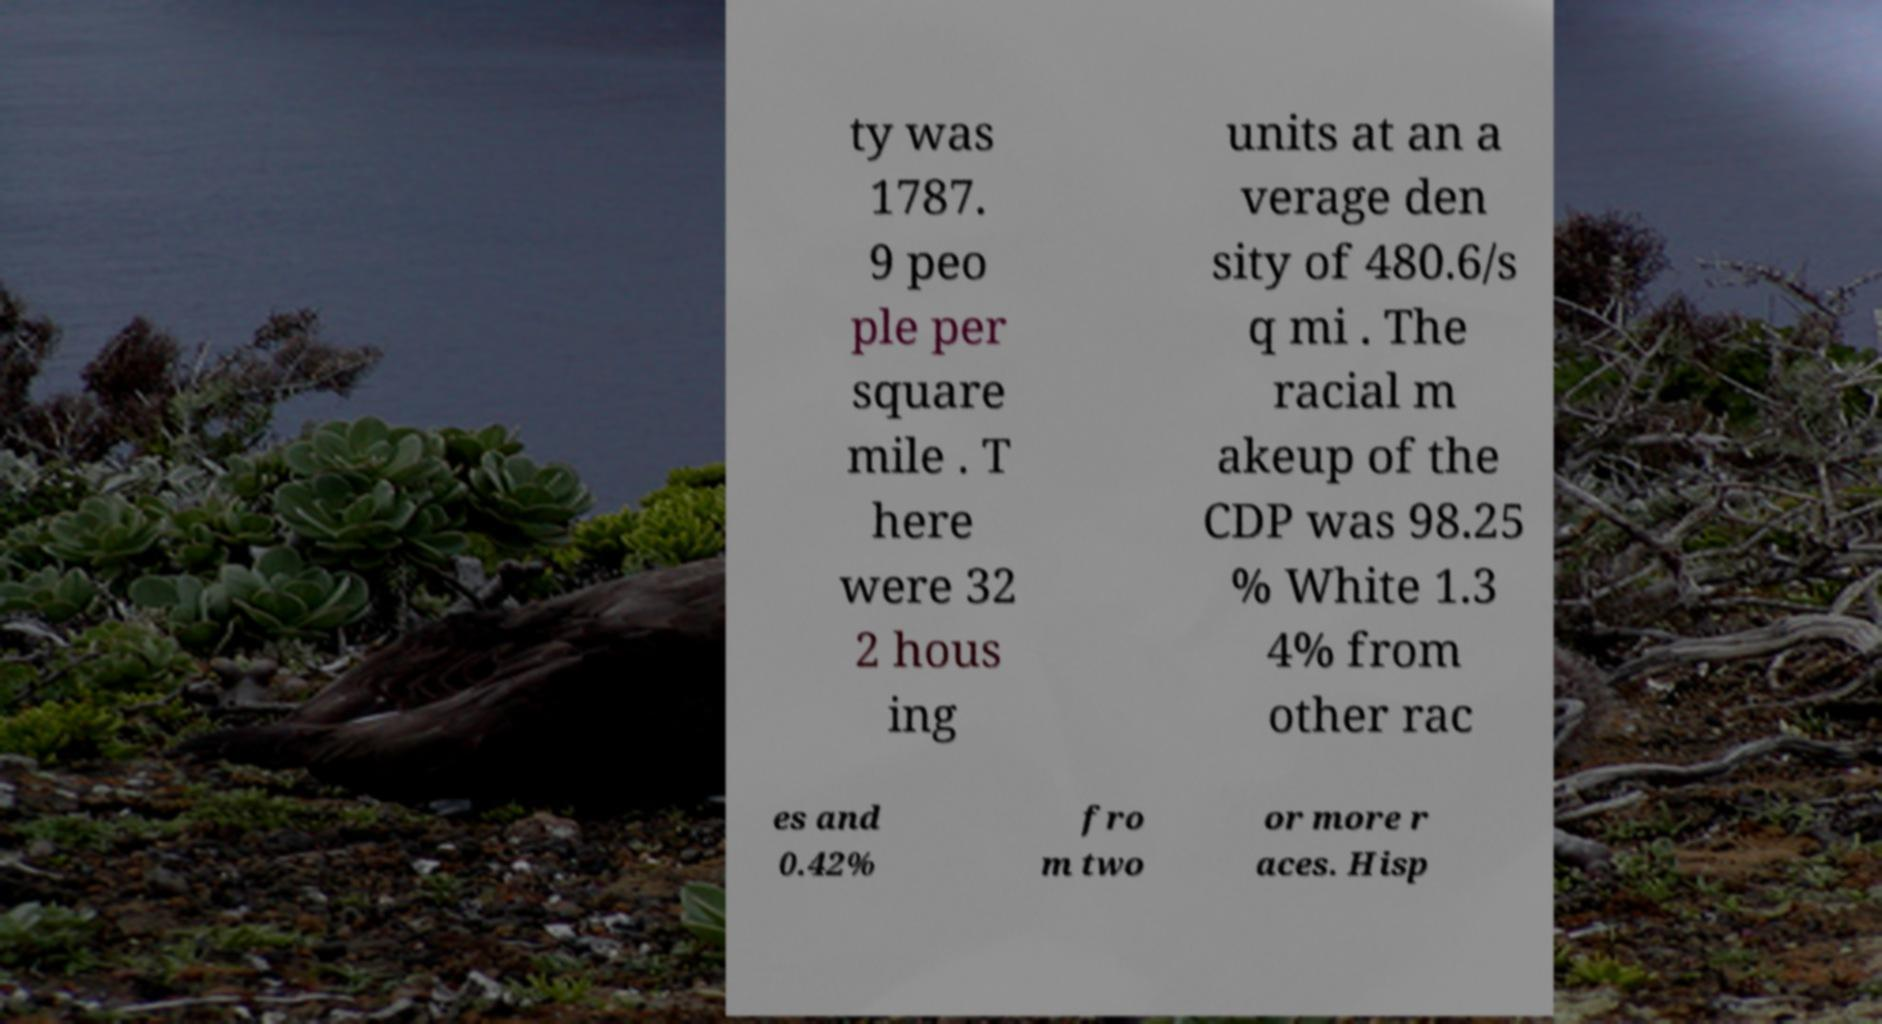Please identify and transcribe the text found in this image. ty was 1787. 9 peo ple per square mile . T here were 32 2 hous ing units at an a verage den sity of 480.6/s q mi . The racial m akeup of the CDP was 98.25 % White 1.3 4% from other rac es and 0.42% fro m two or more r aces. Hisp 